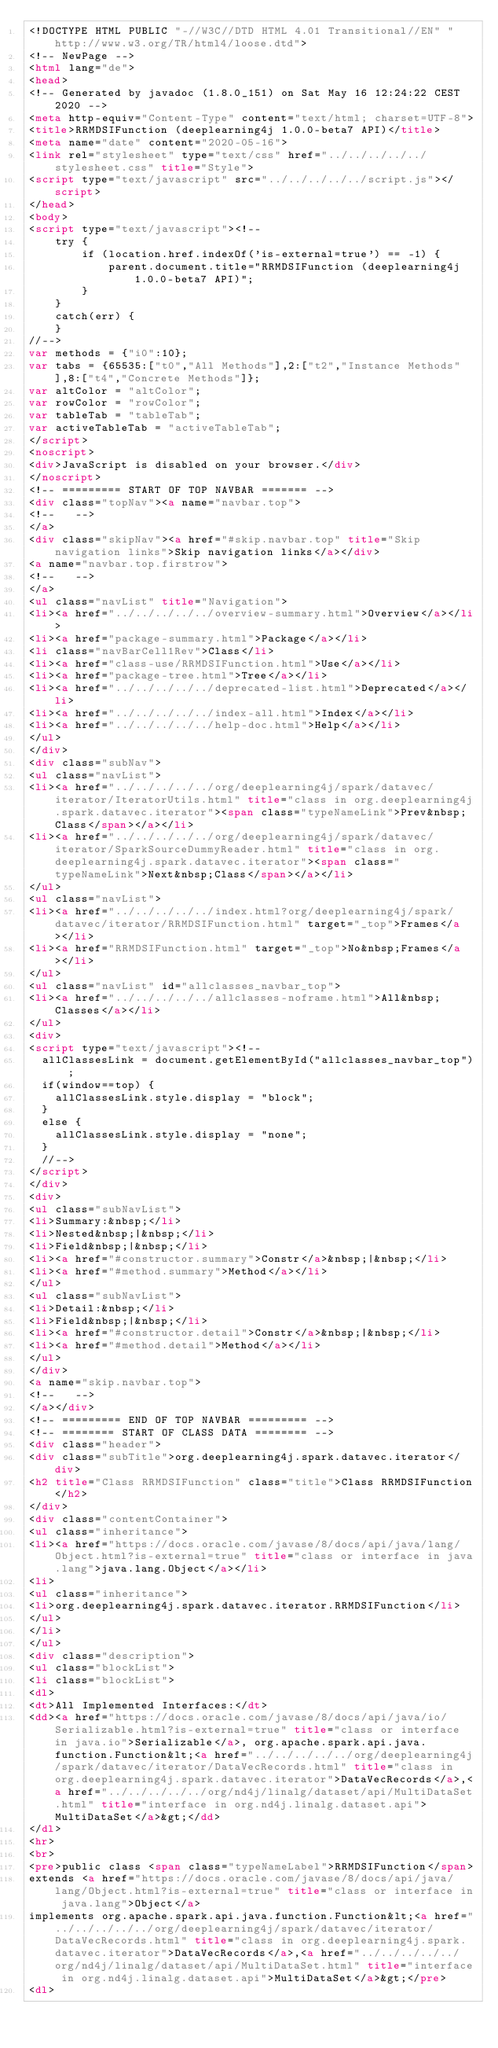<code> <loc_0><loc_0><loc_500><loc_500><_HTML_><!DOCTYPE HTML PUBLIC "-//W3C//DTD HTML 4.01 Transitional//EN" "http://www.w3.org/TR/html4/loose.dtd">
<!-- NewPage -->
<html lang="de">
<head>
<!-- Generated by javadoc (1.8.0_151) on Sat May 16 12:24:22 CEST 2020 -->
<meta http-equiv="Content-Type" content="text/html; charset=UTF-8">
<title>RRMDSIFunction (deeplearning4j 1.0.0-beta7 API)</title>
<meta name="date" content="2020-05-16">
<link rel="stylesheet" type="text/css" href="../../../../../stylesheet.css" title="Style">
<script type="text/javascript" src="../../../../../script.js"></script>
</head>
<body>
<script type="text/javascript"><!--
    try {
        if (location.href.indexOf('is-external=true') == -1) {
            parent.document.title="RRMDSIFunction (deeplearning4j 1.0.0-beta7 API)";
        }
    }
    catch(err) {
    }
//-->
var methods = {"i0":10};
var tabs = {65535:["t0","All Methods"],2:["t2","Instance Methods"],8:["t4","Concrete Methods"]};
var altColor = "altColor";
var rowColor = "rowColor";
var tableTab = "tableTab";
var activeTableTab = "activeTableTab";
</script>
<noscript>
<div>JavaScript is disabled on your browser.</div>
</noscript>
<!-- ========= START OF TOP NAVBAR ======= -->
<div class="topNav"><a name="navbar.top">
<!--   -->
</a>
<div class="skipNav"><a href="#skip.navbar.top" title="Skip navigation links">Skip navigation links</a></div>
<a name="navbar.top.firstrow">
<!--   -->
</a>
<ul class="navList" title="Navigation">
<li><a href="../../../../../overview-summary.html">Overview</a></li>
<li><a href="package-summary.html">Package</a></li>
<li class="navBarCell1Rev">Class</li>
<li><a href="class-use/RRMDSIFunction.html">Use</a></li>
<li><a href="package-tree.html">Tree</a></li>
<li><a href="../../../../../deprecated-list.html">Deprecated</a></li>
<li><a href="../../../../../index-all.html">Index</a></li>
<li><a href="../../../../../help-doc.html">Help</a></li>
</ul>
</div>
<div class="subNav">
<ul class="navList">
<li><a href="../../../../../org/deeplearning4j/spark/datavec/iterator/IteratorUtils.html" title="class in org.deeplearning4j.spark.datavec.iterator"><span class="typeNameLink">Prev&nbsp;Class</span></a></li>
<li><a href="../../../../../org/deeplearning4j/spark/datavec/iterator/SparkSourceDummyReader.html" title="class in org.deeplearning4j.spark.datavec.iterator"><span class="typeNameLink">Next&nbsp;Class</span></a></li>
</ul>
<ul class="navList">
<li><a href="../../../../../index.html?org/deeplearning4j/spark/datavec/iterator/RRMDSIFunction.html" target="_top">Frames</a></li>
<li><a href="RRMDSIFunction.html" target="_top">No&nbsp;Frames</a></li>
</ul>
<ul class="navList" id="allclasses_navbar_top">
<li><a href="../../../../../allclasses-noframe.html">All&nbsp;Classes</a></li>
</ul>
<div>
<script type="text/javascript"><!--
  allClassesLink = document.getElementById("allclasses_navbar_top");
  if(window==top) {
    allClassesLink.style.display = "block";
  }
  else {
    allClassesLink.style.display = "none";
  }
  //-->
</script>
</div>
<div>
<ul class="subNavList">
<li>Summary:&nbsp;</li>
<li>Nested&nbsp;|&nbsp;</li>
<li>Field&nbsp;|&nbsp;</li>
<li><a href="#constructor.summary">Constr</a>&nbsp;|&nbsp;</li>
<li><a href="#method.summary">Method</a></li>
</ul>
<ul class="subNavList">
<li>Detail:&nbsp;</li>
<li>Field&nbsp;|&nbsp;</li>
<li><a href="#constructor.detail">Constr</a>&nbsp;|&nbsp;</li>
<li><a href="#method.detail">Method</a></li>
</ul>
</div>
<a name="skip.navbar.top">
<!--   -->
</a></div>
<!-- ========= END OF TOP NAVBAR ========= -->
<!-- ======== START OF CLASS DATA ======== -->
<div class="header">
<div class="subTitle">org.deeplearning4j.spark.datavec.iterator</div>
<h2 title="Class RRMDSIFunction" class="title">Class RRMDSIFunction</h2>
</div>
<div class="contentContainer">
<ul class="inheritance">
<li><a href="https://docs.oracle.com/javase/8/docs/api/java/lang/Object.html?is-external=true" title="class or interface in java.lang">java.lang.Object</a></li>
<li>
<ul class="inheritance">
<li>org.deeplearning4j.spark.datavec.iterator.RRMDSIFunction</li>
</ul>
</li>
</ul>
<div class="description">
<ul class="blockList">
<li class="blockList">
<dl>
<dt>All Implemented Interfaces:</dt>
<dd><a href="https://docs.oracle.com/javase/8/docs/api/java/io/Serializable.html?is-external=true" title="class or interface in java.io">Serializable</a>, org.apache.spark.api.java.function.Function&lt;<a href="../../../../../org/deeplearning4j/spark/datavec/iterator/DataVecRecords.html" title="class in org.deeplearning4j.spark.datavec.iterator">DataVecRecords</a>,<a href="../../../../../org/nd4j/linalg/dataset/api/MultiDataSet.html" title="interface in org.nd4j.linalg.dataset.api">MultiDataSet</a>&gt;</dd>
</dl>
<hr>
<br>
<pre>public class <span class="typeNameLabel">RRMDSIFunction</span>
extends <a href="https://docs.oracle.com/javase/8/docs/api/java/lang/Object.html?is-external=true" title="class or interface in java.lang">Object</a>
implements org.apache.spark.api.java.function.Function&lt;<a href="../../../../../org/deeplearning4j/spark/datavec/iterator/DataVecRecords.html" title="class in org.deeplearning4j.spark.datavec.iterator">DataVecRecords</a>,<a href="../../../../../org/nd4j/linalg/dataset/api/MultiDataSet.html" title="interface in org.nd4j.linalg.dataset.api">MultiDataSet</a>&gt;</pre>
<dl></code> 